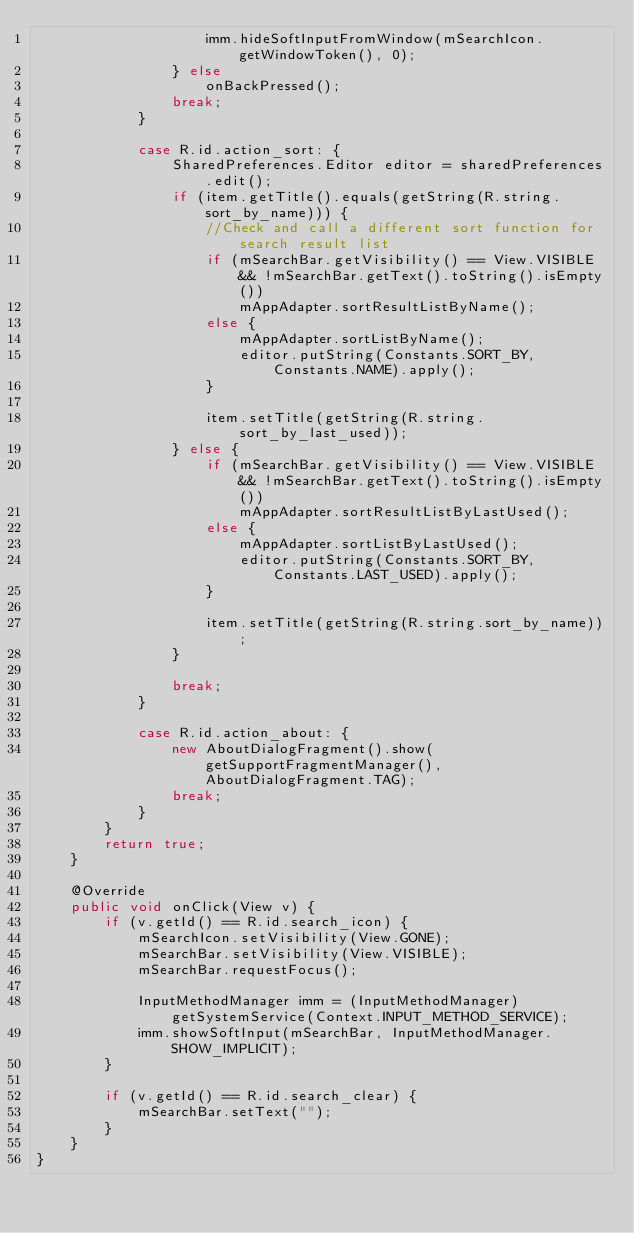<code> <loc_0><loc_0><loc_500><loc_500><_Java_>                    imm.hideSoftInputFromWindow(mSearchIcon.getWindowToken(), 0);
                } else
                    onBackPressed();
                break;
            }

            case R.id.action_sort: {
                SharedPreferences.Editor editor = sharedPreferences.edit();
                if (item.getTitle().equals(getString(R.string.sort_by_name))) {
                    //Check and call a different sort function for search result list
                    if (mSearchBar.getVisibility() == View.VISIBLE && !mSearchBar.getText().toString().isEmpty())
                        mAppAdapter.sortResultListByName();
                    else {
                        mAppAdapter.sortListByName();
                        editor.putString(Constants.SORT_BY, Constants.NAME).apply();
                    }

                    item.setTitle(getString(R.string.sort_by_last_used));
                } else {
                    if (mSearchBar.getVisibility() == View.VISIBLE && !mSearchBar.getText().toString().isEmpty())
                        mAppAdapter.sortResultListByLastUsed();
                    else {
                        mAppAdapter.sortListByLastUsed();
                        editor.putString(Constants.SORT_BY, Constants.LAST_USED).apply();
                    }

                    item.setTitle(getString(R.string.sort_by_name));
                }

                break;
            }

            case R.id.action_about: {
                new AboutDialogFragment().show(getSupportFragmentManager(), AboutDialogFragment.TAG);
                break;
            }
        }
        return true;
    }

    @Override
    public void onClick(View v) {
        if (v.getId() == R.id.search_icon) {
            mSearchIcon.setVisibility(View.GONE);
            mSearchBar.setVisibility(View.VISIBLE);
            mSearchBar.requestFocus();

            InputMethodManager imm = (InputMethodManager) getSystemService(Context.INPUT_METHOD_SERVICE);
            imm.showSoftInput(mSearchBar, InputMethodManager.SHOW_IMPLICIT);
        }

        if (v.getId() == R.id.search_clear) {
            mSearchBar.setText("");
        }
    }
}
</code> 